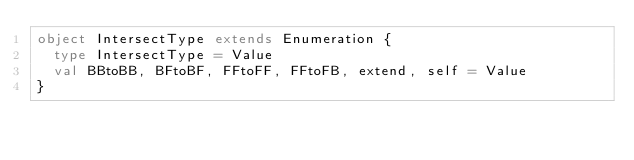<code> <loc_0><loc_0><loc_500><loc_500><_Scala_>object IntersectType extends Enumeration {
  type IntersectType = Value
  val BBtoBB, BFtoBF, FFtoFF, FFtoFB, extend, self = Value
}</code> 